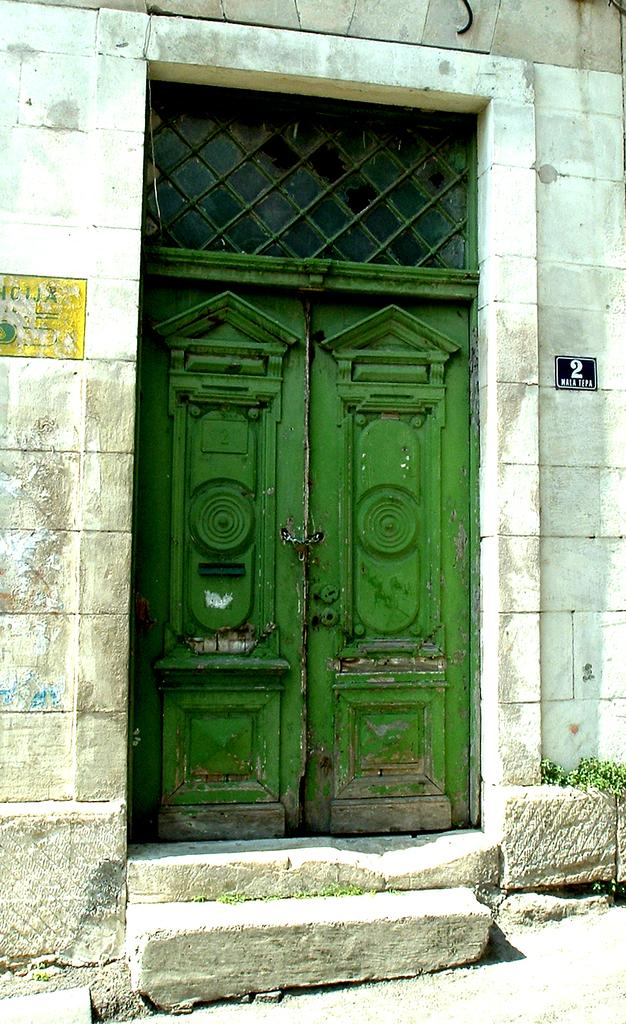What type of structure is visible in the image? There is a building in the image. How many eyes can be seen on the building in the image? Buildings do not have eyes, so this question cannot be answered based on the information provided. 